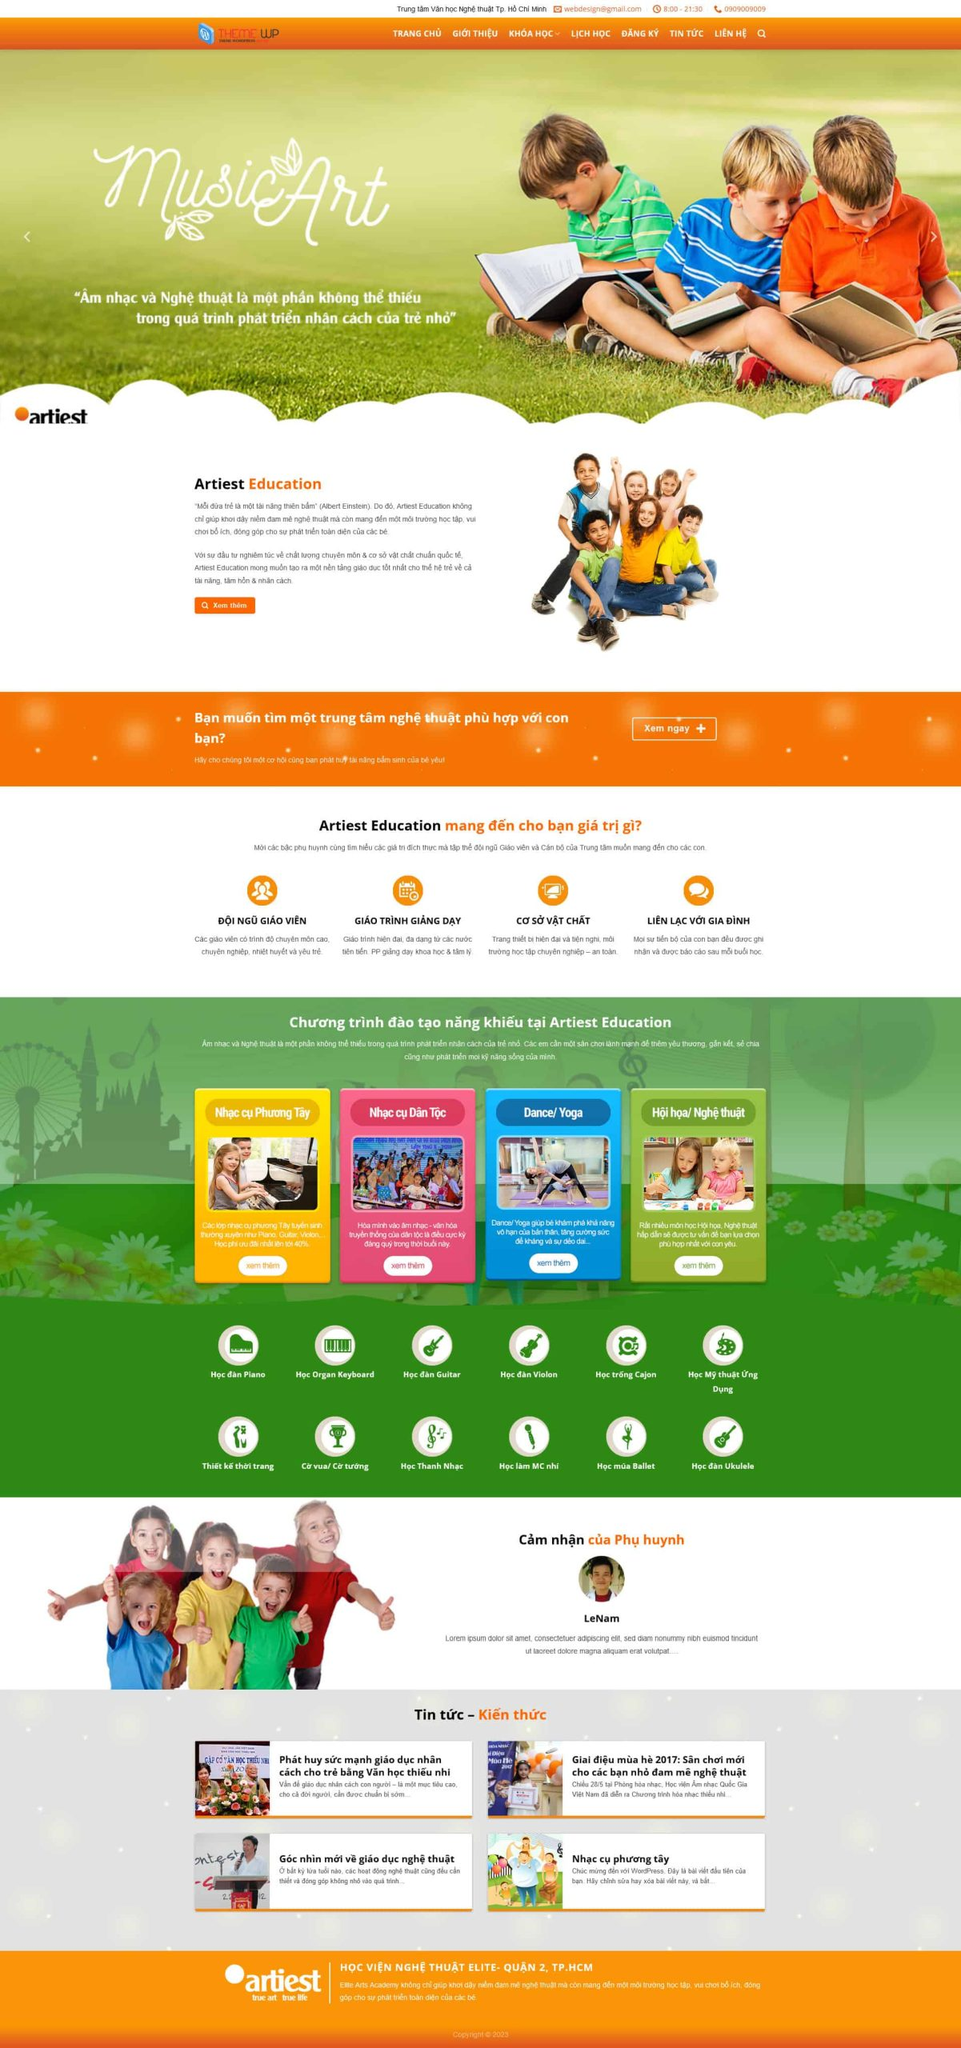Liệt kê 5 ngành nghề, lĩnh vực phù hợp với website này, phân cách các màu sắc bằng dấu phẩy. Chỉ trả về kết quả, phân cách bằng dấy phẩy
 Giáo dục, Nghệ thuật, Âm nhạc, Đào tạo tài năng, Vui chơi giải trí 